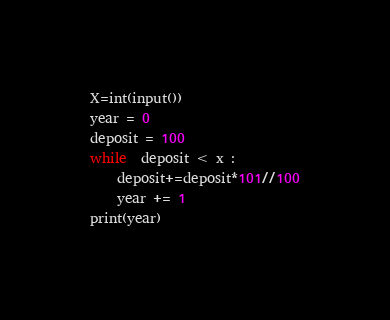<code> <loc_0><loc_0><loc_500><loc_500><_Python_>X=int(input())
year = 0
deposit = 100 
while  deposit < x :
    deposit+=deposit*101//100
    year += 1
print(year) 
</code> 